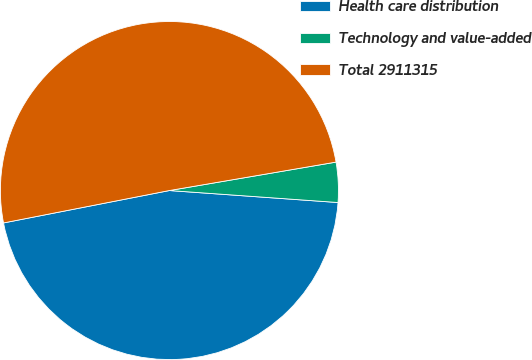Convert chart to OTSL. <chart><loc_0><loc_0><loc_500><loc_500><pie_chart><fcel>Health care distribution<fcel>Technology and value-added<fcel>Total 2911315<nl><fcel>45.8%<fcel>3.82%<fcel>50.38%<nl></chart> 